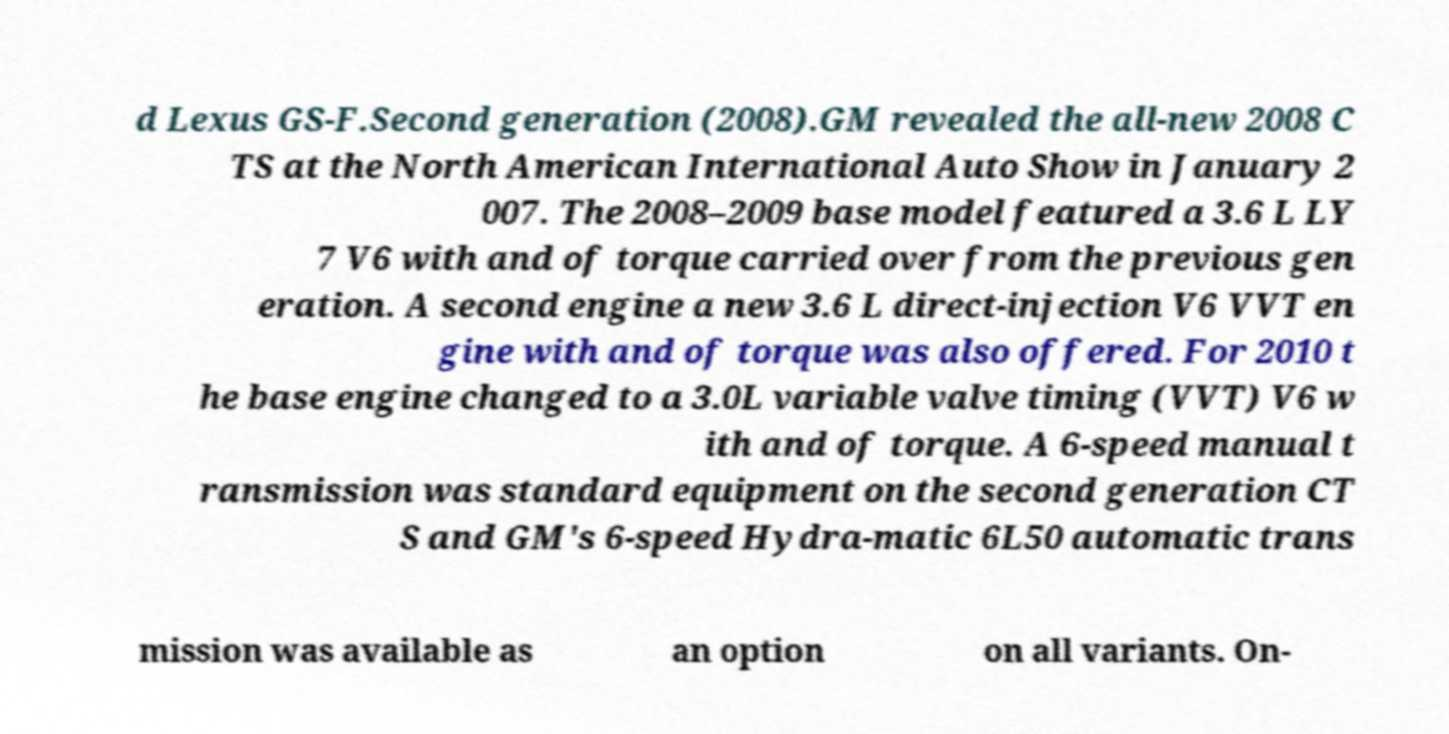I need the written content from this picture converted into text. Can you do that? d Lexus GS-F.Second generation (2008).GM revealed the all-new 2008 C TS at the North American International Auto Show in January 2 007. The 2008–2009 base model featured a 3.6 L LY 7 V6 with and of torque carried over from the previous gen eration. A second engine a new 3.6 L direct-injection V6 VVT en gine with and of torque was also offered. For 2010 t he base engine changed to a 3.0L variable valve timing (VVT) V6 w ith and of torque. A 6-speed manual t ransmission was standard equipment on the second generation CT S and GM's 6-speed Hydra-matic 6L50 automatic trans mission was available as an option on all variants. On- 